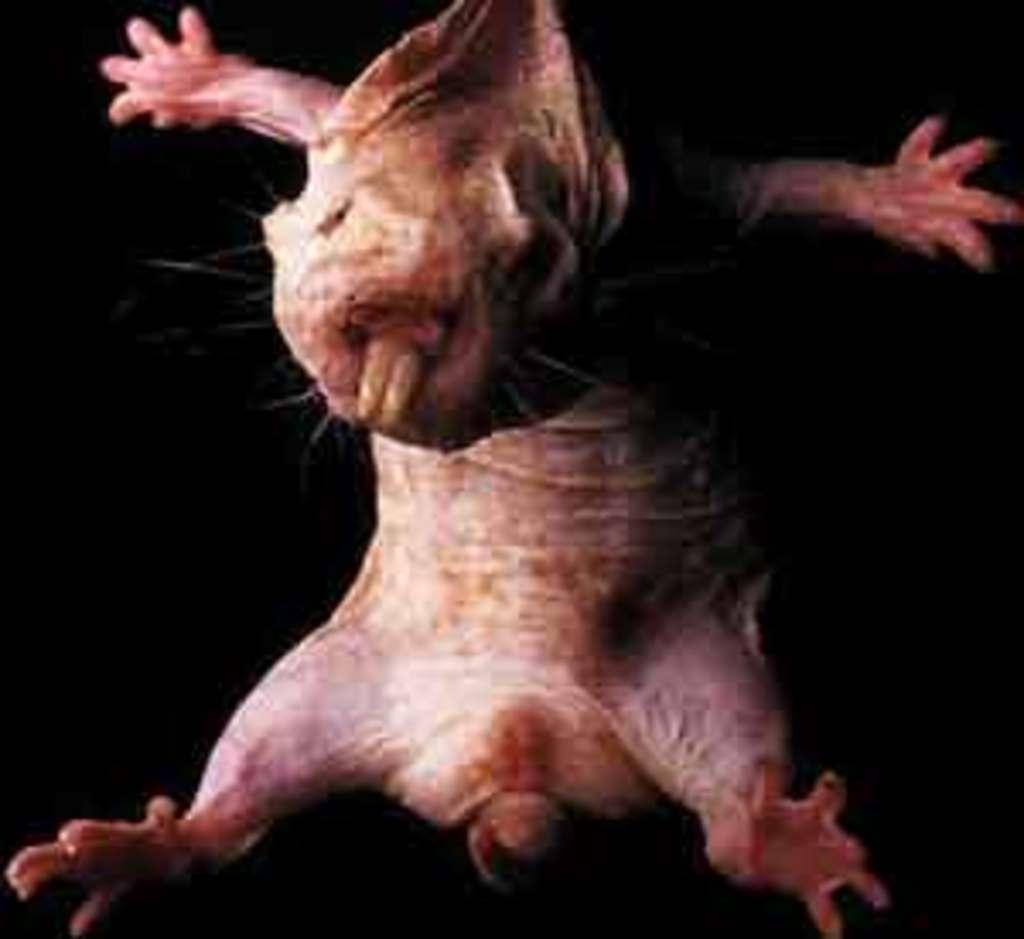How would you summarize this image in a sentence or two? In this image there is a pig. 